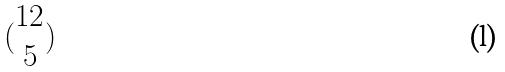<formula> <loc_0><loc_0><loc_500><loc_500>( \begin{matrix} 1 2 \\ 5 \end{matrix} )</formula> 